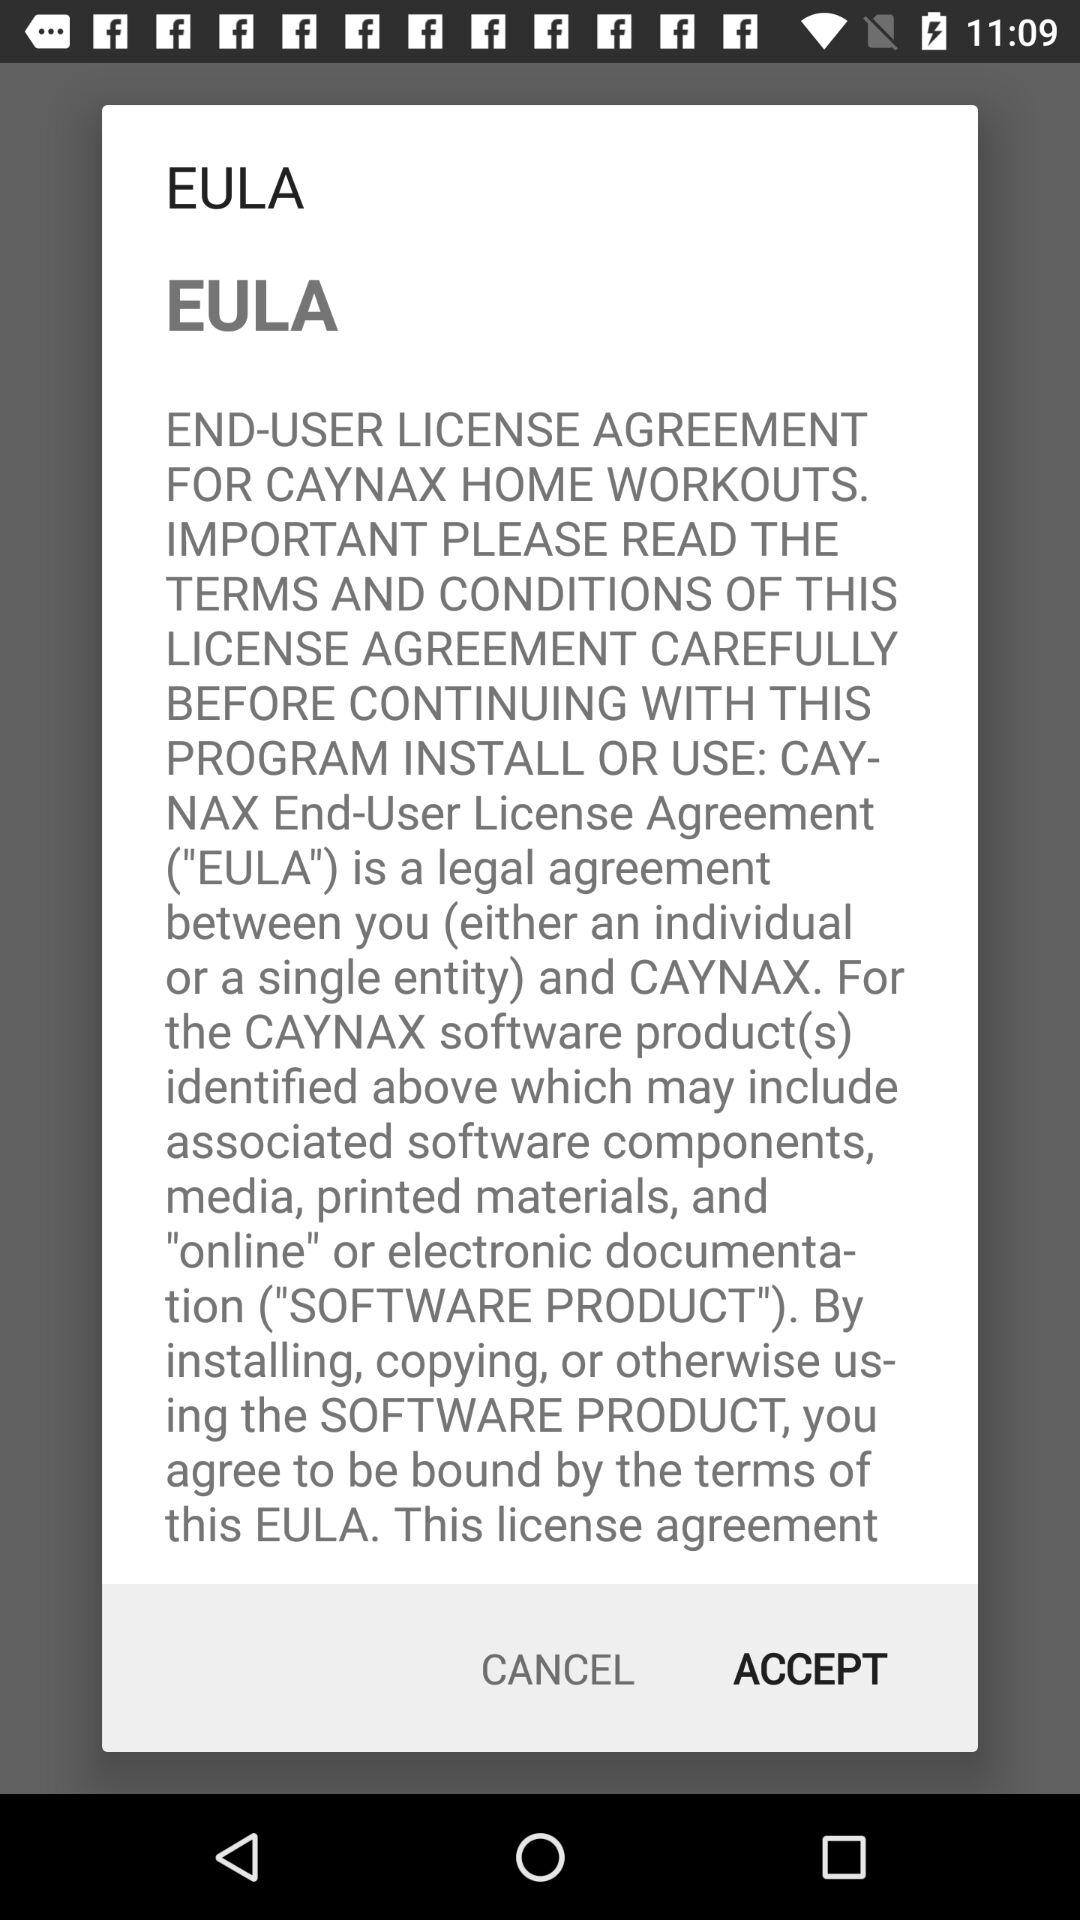What is the application name? The application name is "CAYNAX HOME WORKOUTS". 